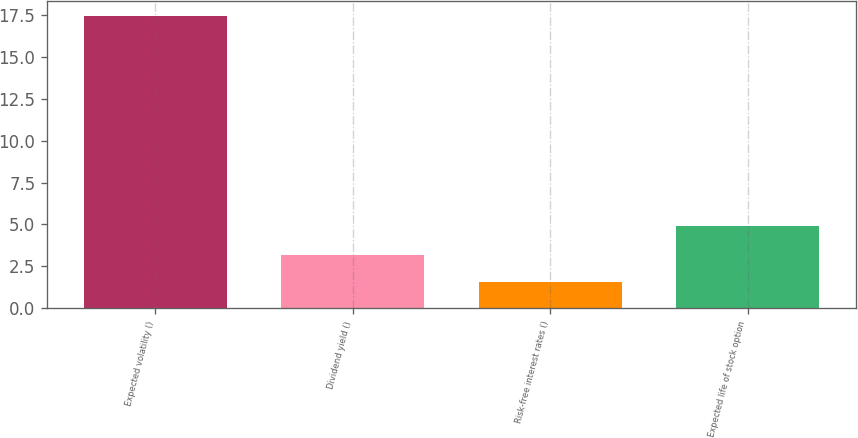Convert chart. <chart><loc_0><loc_0><loc_500><loc_500><bar_chart><fcel>Expected volatility ()<fcel>Dividend yield ()<fcel>Risk-free interest rates ()<fcel>Expected life of stock option<nl><fcel>17.45<fcel>3.17<fcel>1.58<fcel>4.92<nl></chart> 